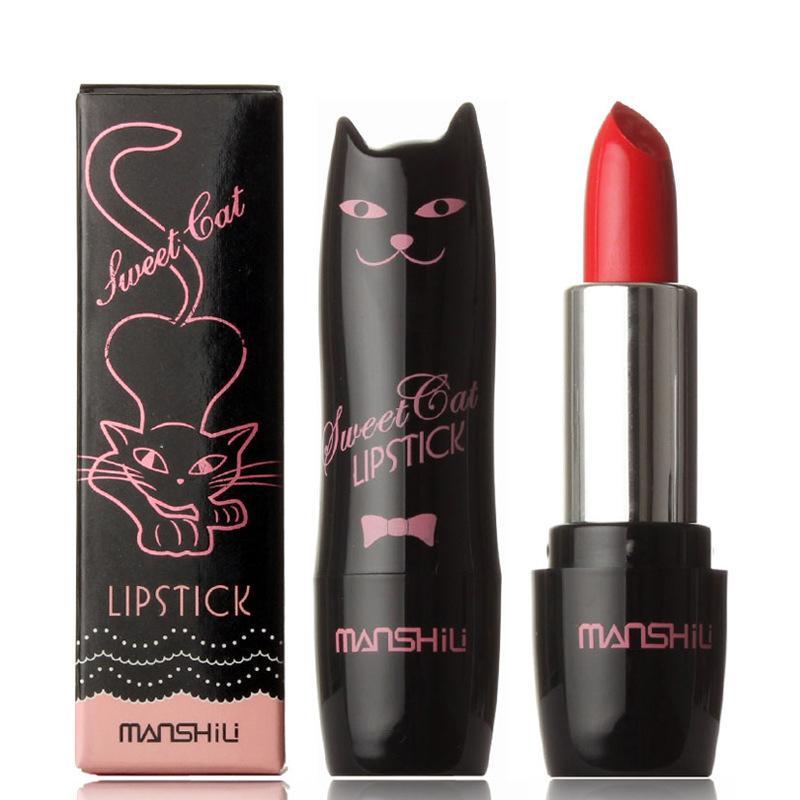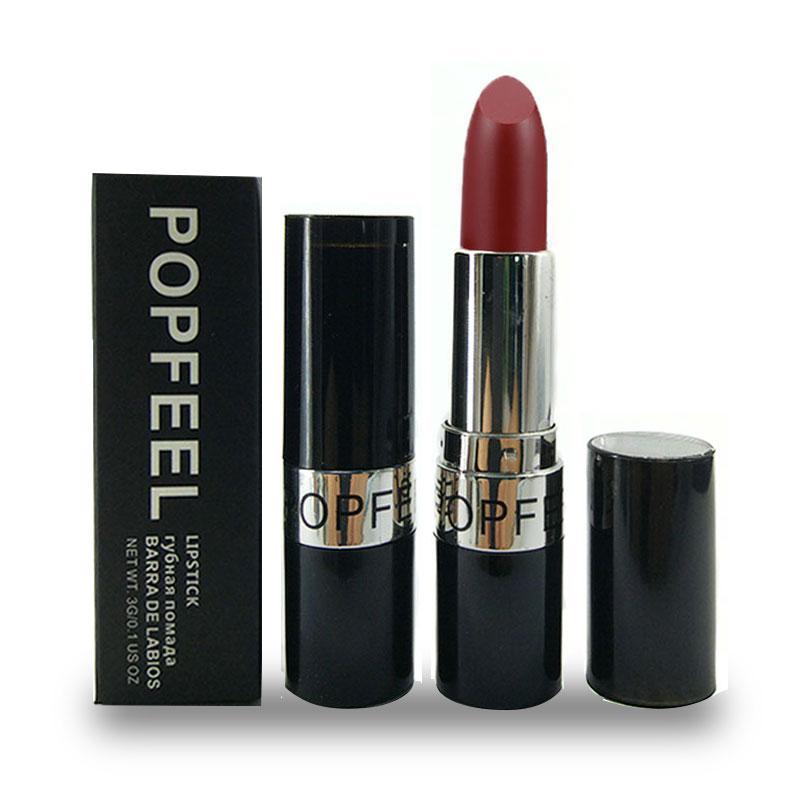The first image is the image on the left, the second image is the image on the right. Given the left and right images, does the statement "There are exactly three items in the image on the left." hold true? Answer yes or no. Yes. 